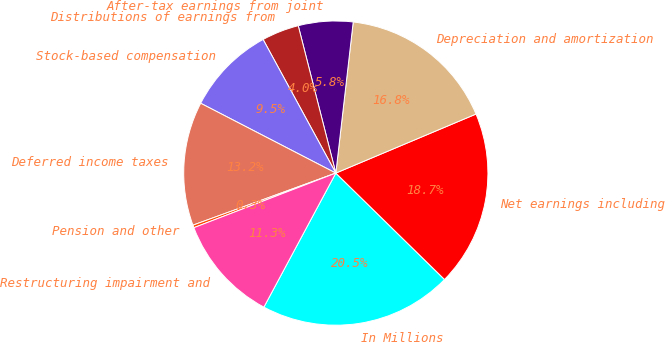<chart> <loc_0><loc_0><loc_500><loc_500><pie_chart><fcel>In Millions<fcel>Net earnings including<fcel>Depreciation and amortization<fcel>After-tax earnings from joint<fcel>Distributions of earnings from<fcel>Stock-based compensation<fcel>Deferred income taxes<fcel>Pension and other<fcel>Restructuring impairment and<nl><fcel>20.52%<fcel>18.68%<fcel>16.84%<fcel>5.8%<fcel>3.96%<fcel>9.48%<fcel>13.16%<fcel>0.28%<fcel>11.32%<nl></chart> 